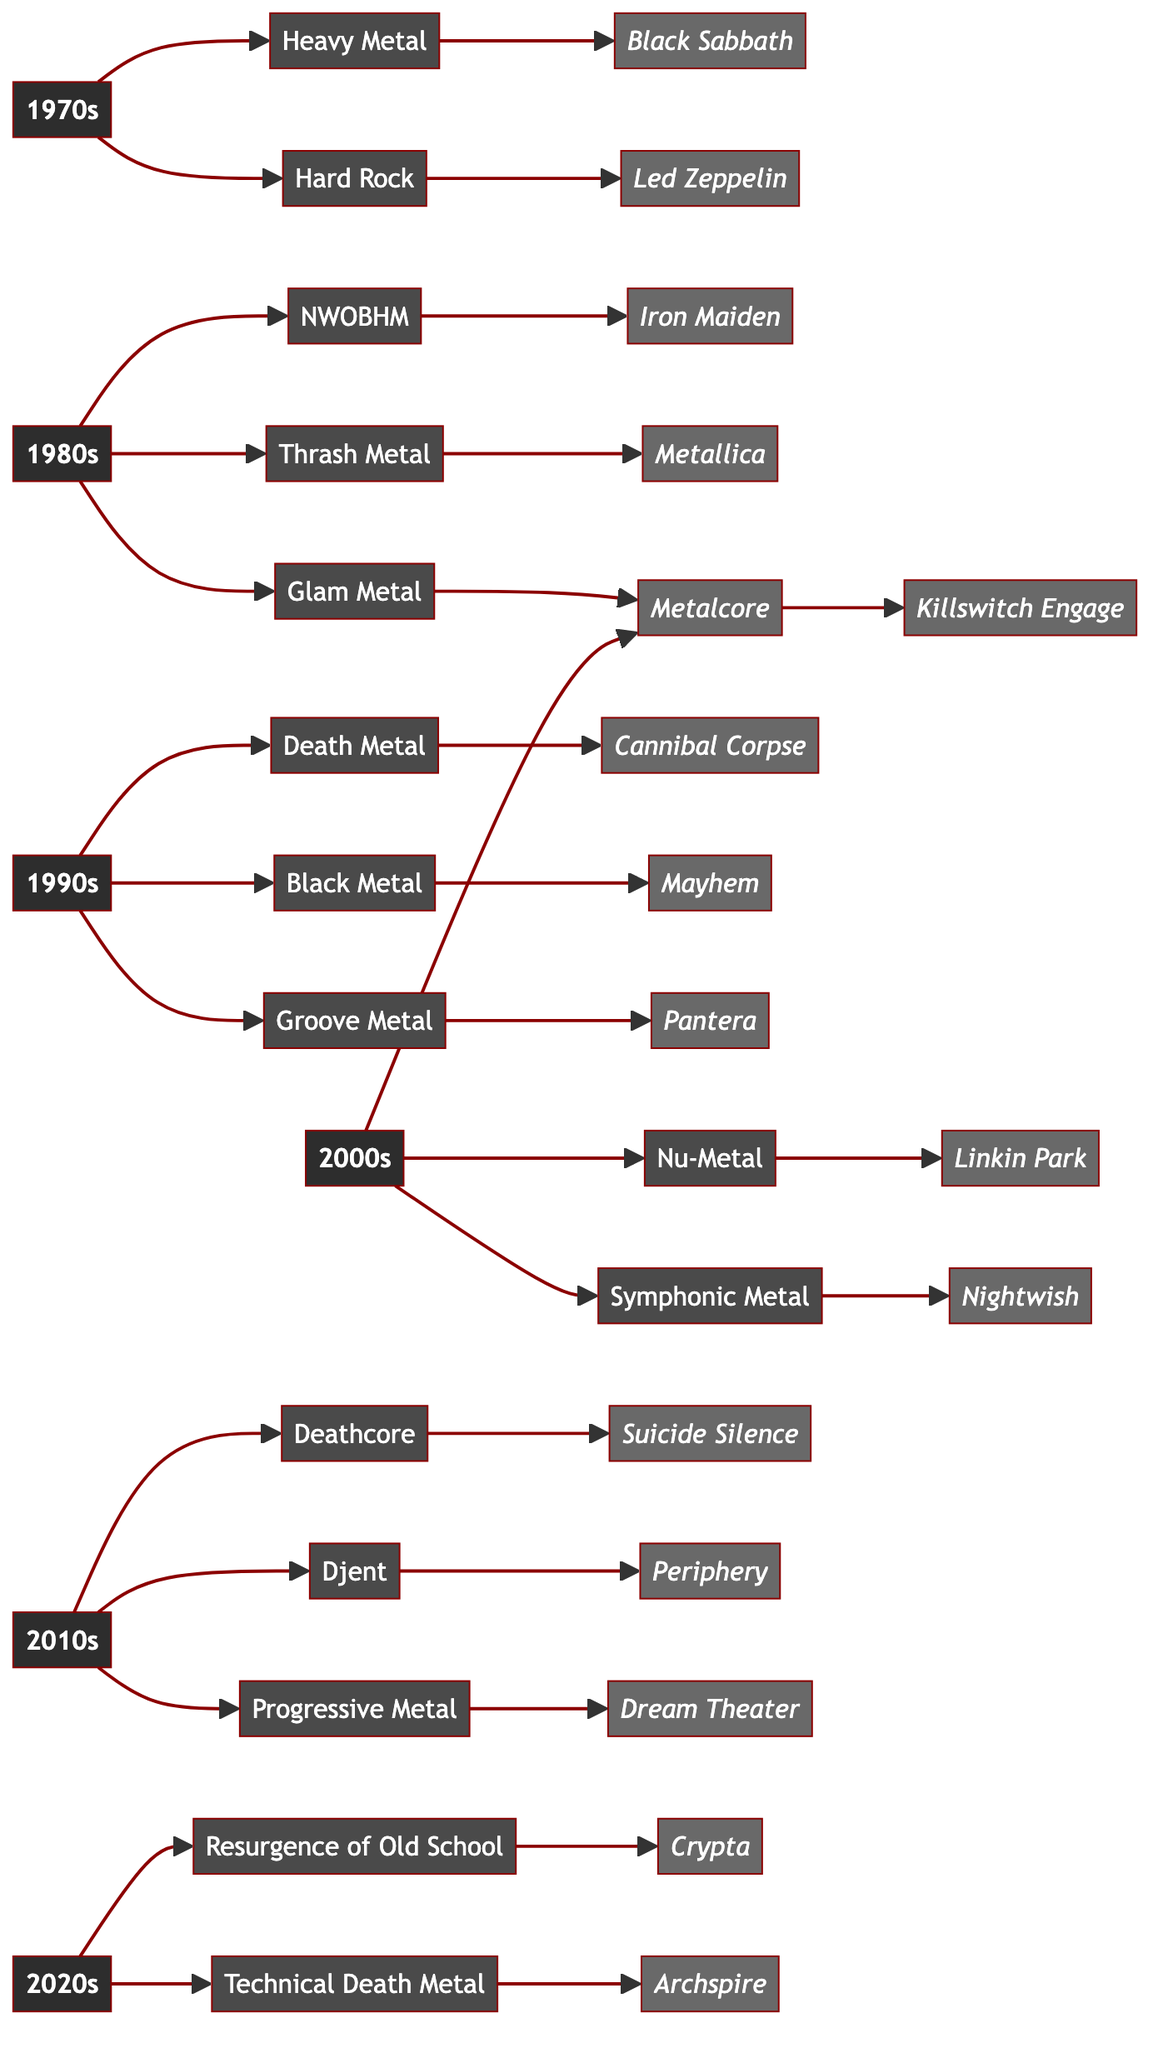What are the key genres of the 1990s? The diagram shows that the key genres for the 1990s are Death Metal, Black Metal, and Groove Metal, which are listed under the 1990s decade node.
Answer: Death Metal, Black Metal, Groove Metal Which band is associated with Glam Metal? According to the flowchart, Mötley Crüe is the band that connects to the Glam Metal genre in the 1980s.
Answer: Mötley Crüe How many key genres are listed for the 2000s? The diagram indicates three key genres for the 2000s: Metalcore, Nu-Metal, and Symphonic Metal. Therefore, the total count is three.
Answer: 3 Which genre was notable in the 2020s? The flowchart identifies the Resurgence of Old School and Technical Death Metal as the notable genres for the 2020s.
Answer: Resurgence of Old School, Technical Death Metal In which decade did Black Sabbath emerge? The flowchart clearly places Black Sabbath under the Heavy Metal genre, which is part of the 1970s section.
Answer: 1970s Who is the iconic band for Technical Death Metal? The diagram specifies Archspire as the iconic band linked to the Technical Death Metal genre in the 2020s.
Answer: Archspire What decade is associated with Iron Maiden? The flowchart indicates that Iron Maiden is associated with the NWOBHM genre in the 1980s.
Answer: 1980s How many iconic bands are listed for the 2010s? Looking at the 2010s section, the diagram lists three bands: Suicide Silence, Periphery, and Dream Theater. Thus, the total is three.
Answer: 3 